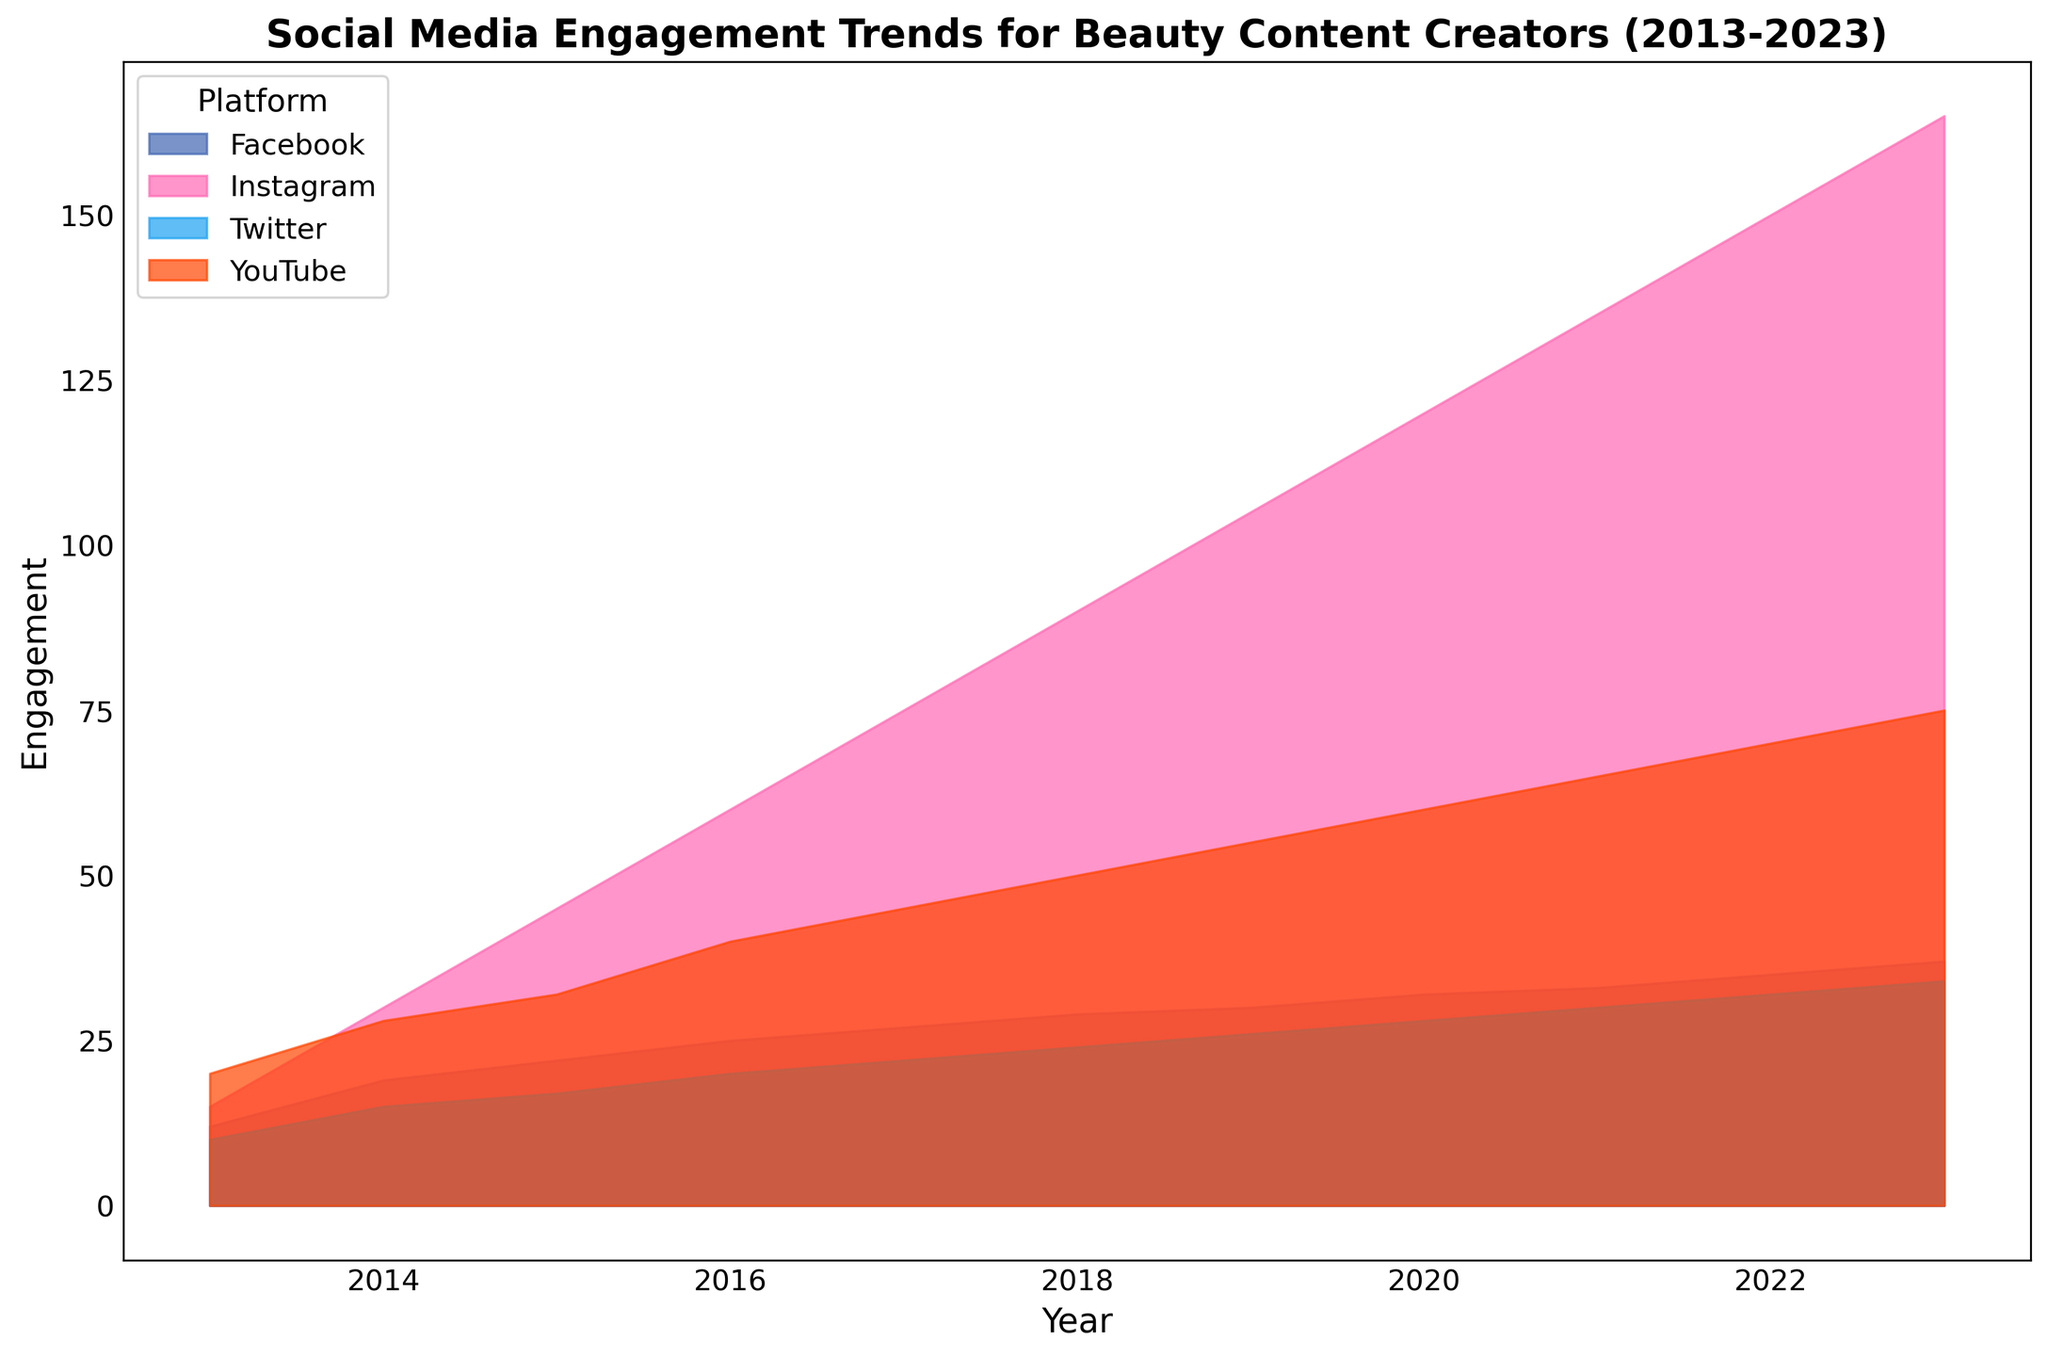Which platform shows the highest engagement in 2023? The chart indicates each platform's engagement by the height of the area. The platform with the highest engagement in 2023 is the one with the tallest area segment.
Answer: Instagram How did the engagement on Twitter change from 2013 to 2023? Examine the heights of the area representing Twitter in 2013 and compare it to the height in 2023. In 2013, Twitter's engagement was 10, and in 2023, it was 34. Engagement increased by 24.
Answer: Increased by 24 Which platform had the most consistent growth in engagement over the decade? Look at the shapes of the areas for each platform and compare their trends over the years. The area for Instagram consistently increases each year without any dips, indicating steady growth.
Answer: Instagram Compare the engagement trends of YouTube and Facebook from 2013 to 2023. Which had a higher growth rate? Calculate the difference in engagement for both platforms between 2013 and 2023. YouTube's engagement increased from 20 to 75 (a growth of 55), and Facebook's increased from 12 to 37 (a growth of 25). YouTube had a higher growth rate.
Answer: YouTube What is the total engagement for all platforms in 2020? Sum the engagement values of all platforms in 2020. Instagram (120) + YouTube (60) + Twitter (28) + Facebook (32) = 240.
Answer: 240 How does the engagement for Instagram in 2016 compare to that of YouTube in 2023? Look at the heights of the areas representing Instagram in 2016 (60) and YouTube in 2023 (75). Instagram in 2016 had lower engagement than YouTube in 2023.
Answer: Lower Which platform had the least engagement growth over the decade? Compare the overall trends and total increases for each platform. Twitter's engagement increased from 10 in 2013 to 34 in 2023, the smallest increase among all platforms.
Answer: Twitter By how much did YouTube's engagement increase from 2013 to 2016? Calculate the difference in YouTube's engagement between 2013 and 2016. In 2013, it was 20, and in 2016, it was 40. The difference is 40 - 20 = 20.
Answer: Increased by 20 What visual feature helps identify the platform with the highest engagement in each year? The height of the area segments for each year visually represents the engagement, making it easy to identify which platform had the highest engagement by comparing heights.
Answer: Height of the area segments Which year saw the largest single-year increase in engagement for Instagram? Observe the steepness and increase in the height of Instagram's area from year to year. The largest increase is from 2018 to 2019, where engagement jumped from 90 to 105, an increase of 15.
Answer: 2018 to 2019 